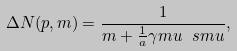Convert formula to latex. <formula><loc_0><loc_0><loc_500><loc_500>\Delta N ( p , m ) = \frac { 1 } { m + \frac { 1 } { a } { \gamma m u \ s m u } } ,</formula> 